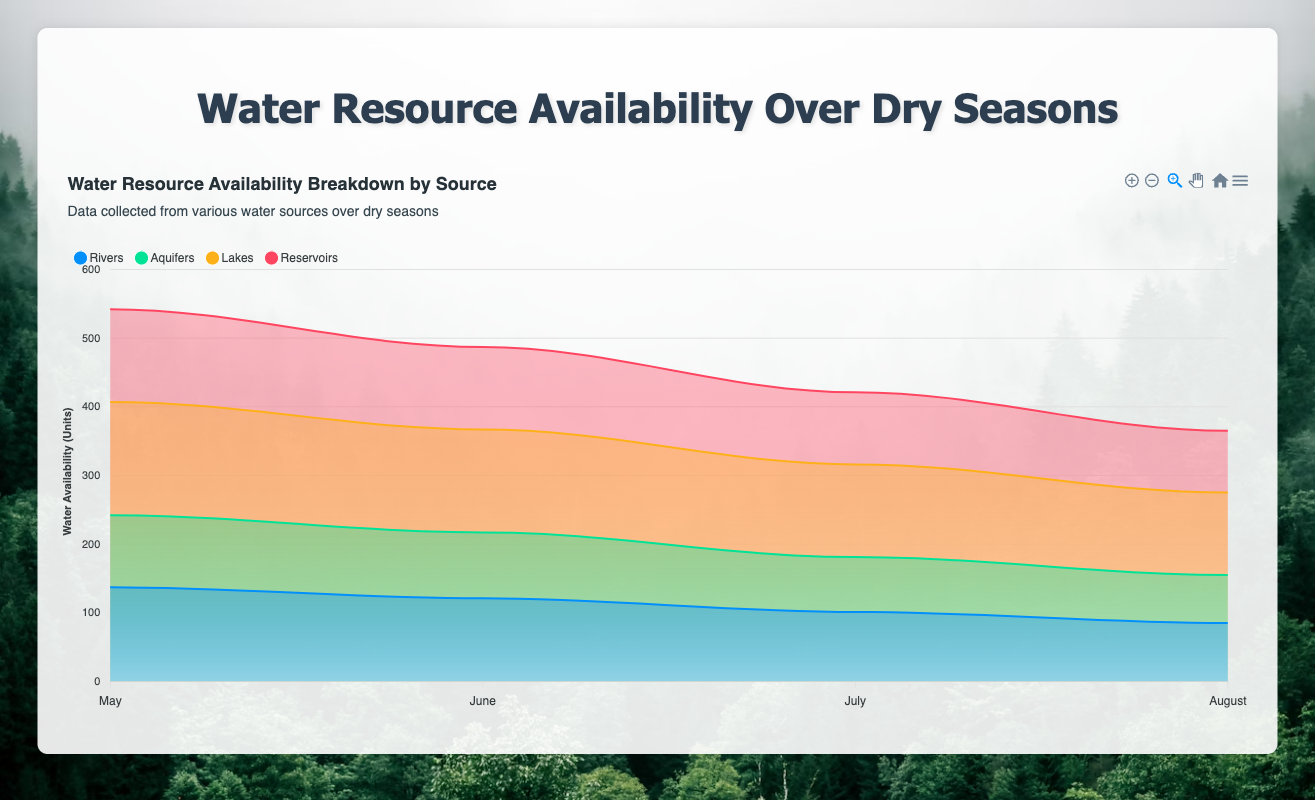What is the total water availability in May across all sources? Add the values for May from each source. Rivers: 137, Aquifers: 105, Lakes: 165, Reservoirs: 135. Total = 137 + 105 + 165 + 135 = 542 units.
Answer: 542 units Which month has the highest total water availability? Compare the total availability in each month: May (542), June (487), July (421), and August (365). May has the highest availability.
Answer: May How does the water availability from Lakes change from May to August? Note the water availability values for Lakes over the months: May (165), June (150), July (135), and August (120). The availability decreases progressively each month.
Answer: Decreases Which source contributes the most to water availability in July? Compare the values for July: Rivers (101), Aquifers (80), Lakes (135), and Reservoirs (105). Lakes contribute the most.
Answer: Lakes By how much does the water availability from Aquifers decrease from May to June? Note the values for Aquifers in May (105) and June (96). The decrease is 105 - 96 = 9 units.
Answer: 9 units Is the rate of decrease in water availability from Rivers consistent across all months? Calculate the difference for each month: May to June (137 - 121 = 16), June to July (121 - 101 = 20), July to August (101 - 85 = 16). The rate is not entirely consistent.
Answer: No Which water resource source shows the least variability in availability over the four months? Calculate the range for each source: Rivers (137-85=52), Aquifers (105-70=35), Lakes (165-120=45), Reservoirs (135-90=45). Aquifers have the least variability.
Answer: Aquifers In which month is the total water availability from Aquifers and Reservoirs equal to the total water availability from Lakes? Compare combined totals: May (Aquifers + Reservoirs = 240, Lakes = 165), June (Aquifers + Reservoirs = 216, Lakes = 150), July (Aquifers + Reservoirs = 185, Lakes = 135), August (Aquifers + Reservoirs = 160, Lakes = 120). There is no month where they are equal.
Answer: None What is the average water availability from Reservoirs over the dry season? Sum the values for Reservoirs over all months: 135 + 120 + 105 + 90 = 450. Divide by 4 months: 450 / 4 = 112.5 units.
Answer: 112.5 units 